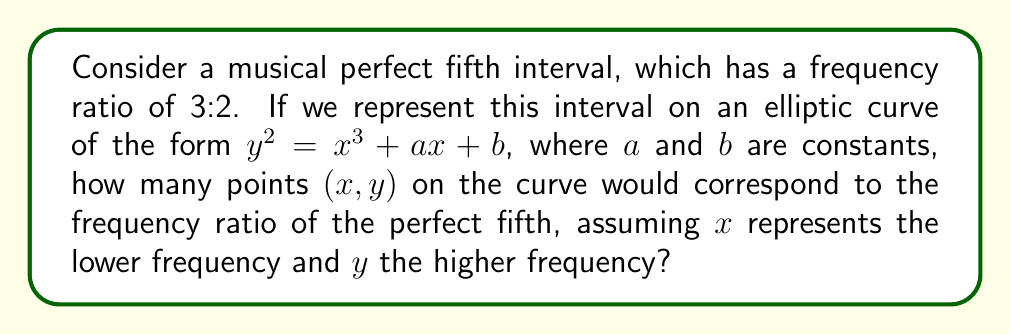Help me with this question. Let's approach this step-by-step:

1) The perfect fifth interval has a frequency ratio of 3:2. This means that if we represent the lower frequency as $x$ and the higher frequency as $y$, we have:

   $\frac{y}{x} = \frac{3}{2}$

2) We can rewrite this as:

   $y = \frac{3}{2}x$

3) Now, let's consider the elliptic curve equation:

   $y^2 = x^3 + ax + b$

4) To find points that correspond to the perfect fifth, we need to substitute our relationship from step 2 into this equation:

   $(\frac{3}{2}x)^2 = x^3 + ax + b$

5) Simplify the left side:

   $\frac{9}{4}x^2 = x^3 + ax + b$

6) Rearrange the equation:

   $x^3 - \frac{9}{4}x^2 + ax + b = 0$

7) This is a cubic equation. In general, a cubic equation can have up to 3 real roots. Each of these roots, if they exist, would represent an $x$-coordinate of a point on the elliptic curve that corresponds to the perfect fifth interval.

8) However, we need to consider that for each $x$-coordinate, there could be two corresponding $y$-coordinates (positive and negative) that satisfy the original elliptic curve equation. This is because the elliptic curve is symmetric about the x-axis.

9) Therefore, the maximum number of points on the elliptic curve that could correspond to the perfect fifth interval is twice the number of real roots of our cubic equation.

10) Thus, there could be up to 6 points on the elliptic curve that correspond to the perfect fifth interval.
Answer: 6 points 